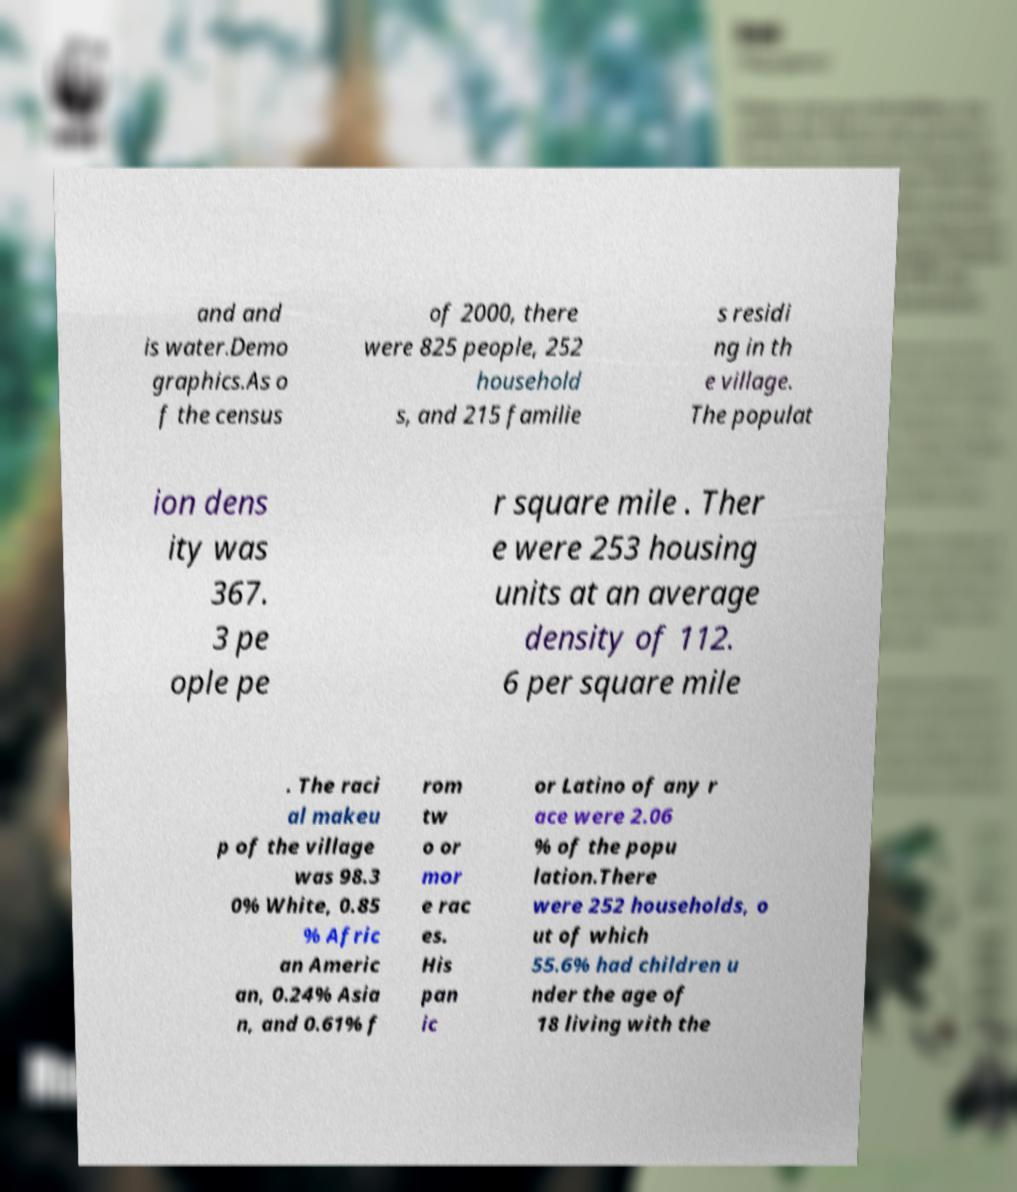Can you accurately transcribe the text from the provided image for me? and and is water.Demo graphics.As o f the census of 2000, there were 825 people, 252 household s, and 215 familie s residi ng in th e village. The populat ion dens ity was 367. 3 pe ople pe r square mile . Ther e were 253 housing units at an average density of 112. 6 per square mile . The raci al makeu p of the village was 98.3 0% White, 0.85 % Afric an Americ an, 0.24% Asia n, and 0.61% f rom tw o or mor e rac es. His pan ic or Latino of any r ace were 2.06 % of the popu lation.There were 252 households, o ut of which 55.6% had children u nder the age of 18 living with the 